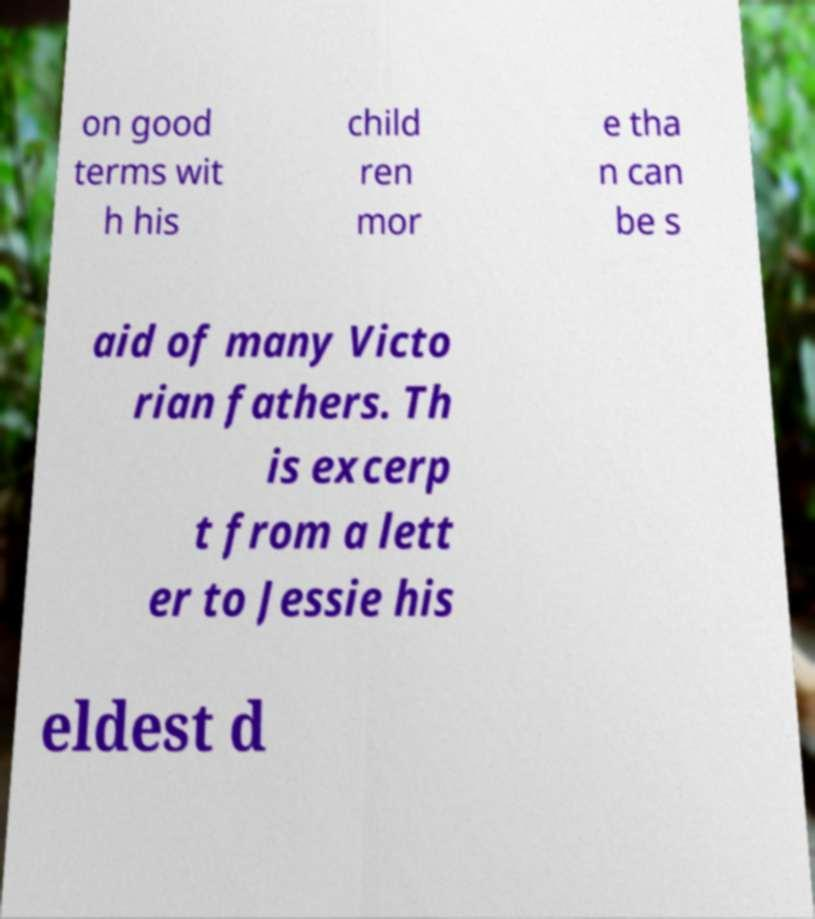I need the written content from this picture converted into text. Can you do that? on good terms wit h his child ren mor e tha n can be s aid of many Victo rian fathers. Th is excerp t from a lett er to Jessie his eldest d 